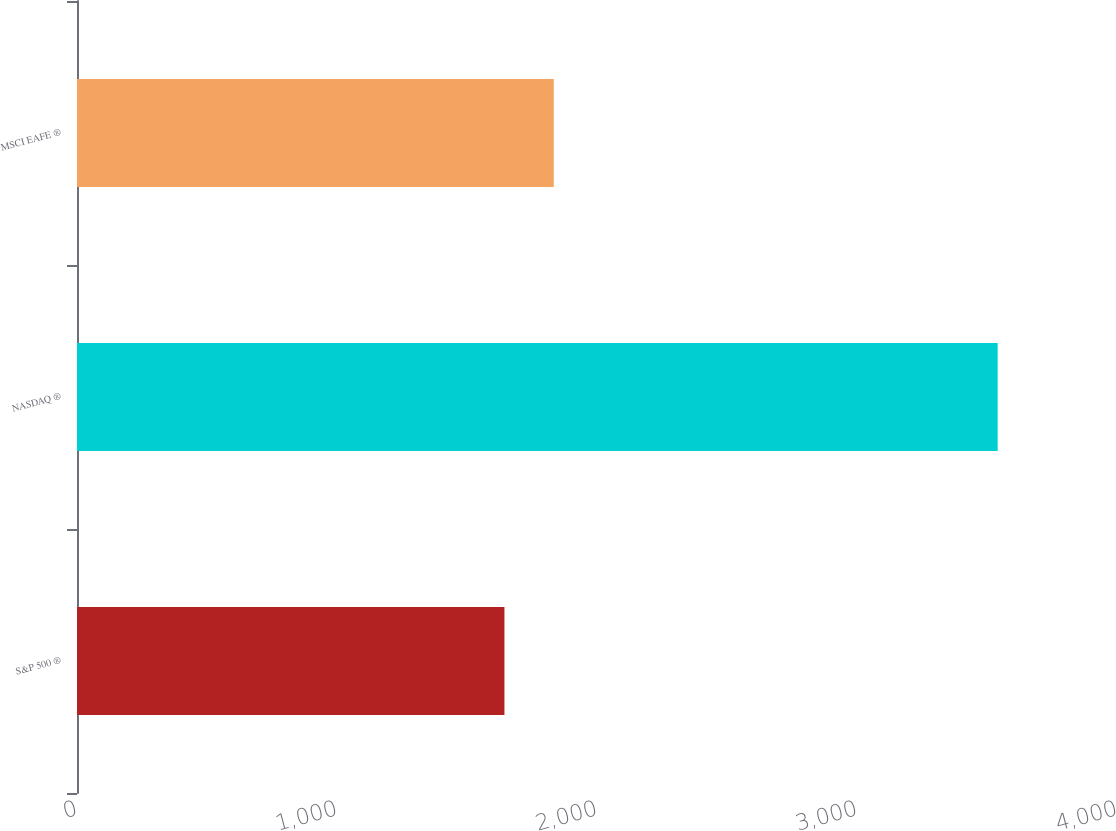Convert chart to OTSL. <chart><loc_0><loc_0><loc_500><loc_500><bar_chart><fcel>S&P 500 ®<fcel>NASDAQ ®<fcel>MSCI EAFE ®<nl><fcel>1644<fcel>3541<fcel>1833.7<nl></chart> 